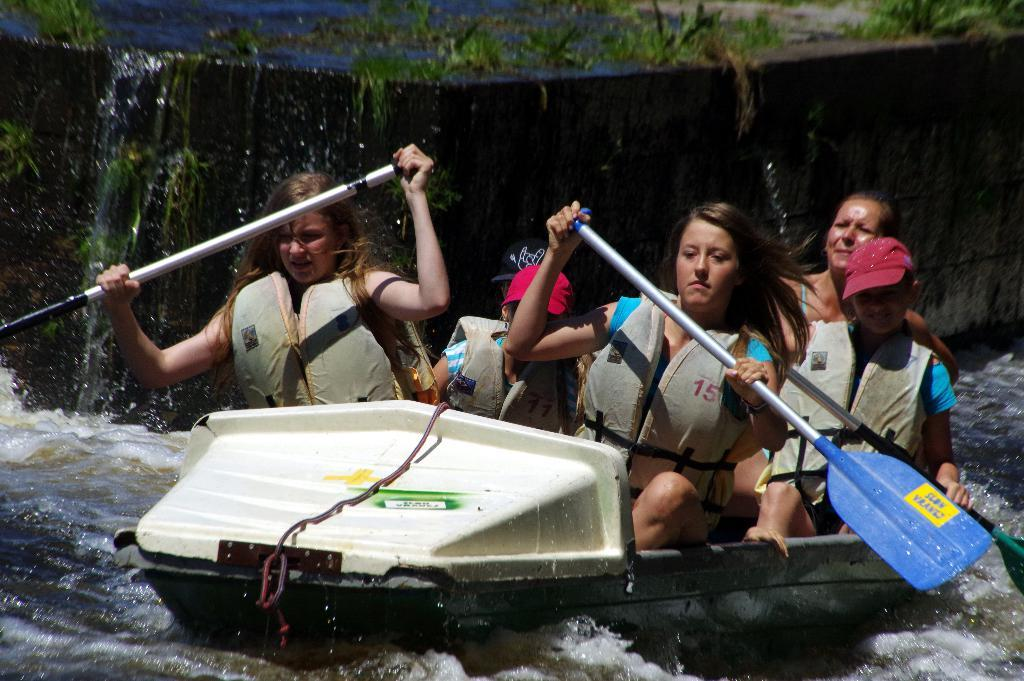What are the people in the image doing? There are people sitting on a boat in the image. What are the women holding in the image? Two women are holding paddles in the image. What can be seen beneath the boat? There is water visible in the image. What type of vegetation is visible in the background of the image? There are plants and grass in the background of the image. What architectural feature is visible in the background of the image? There is a wall in the background of the image. How many snails are crawling on the wall in the image? There are no snails visible in the image; only people, a boat, water, plants, grass, and a wall are present. 